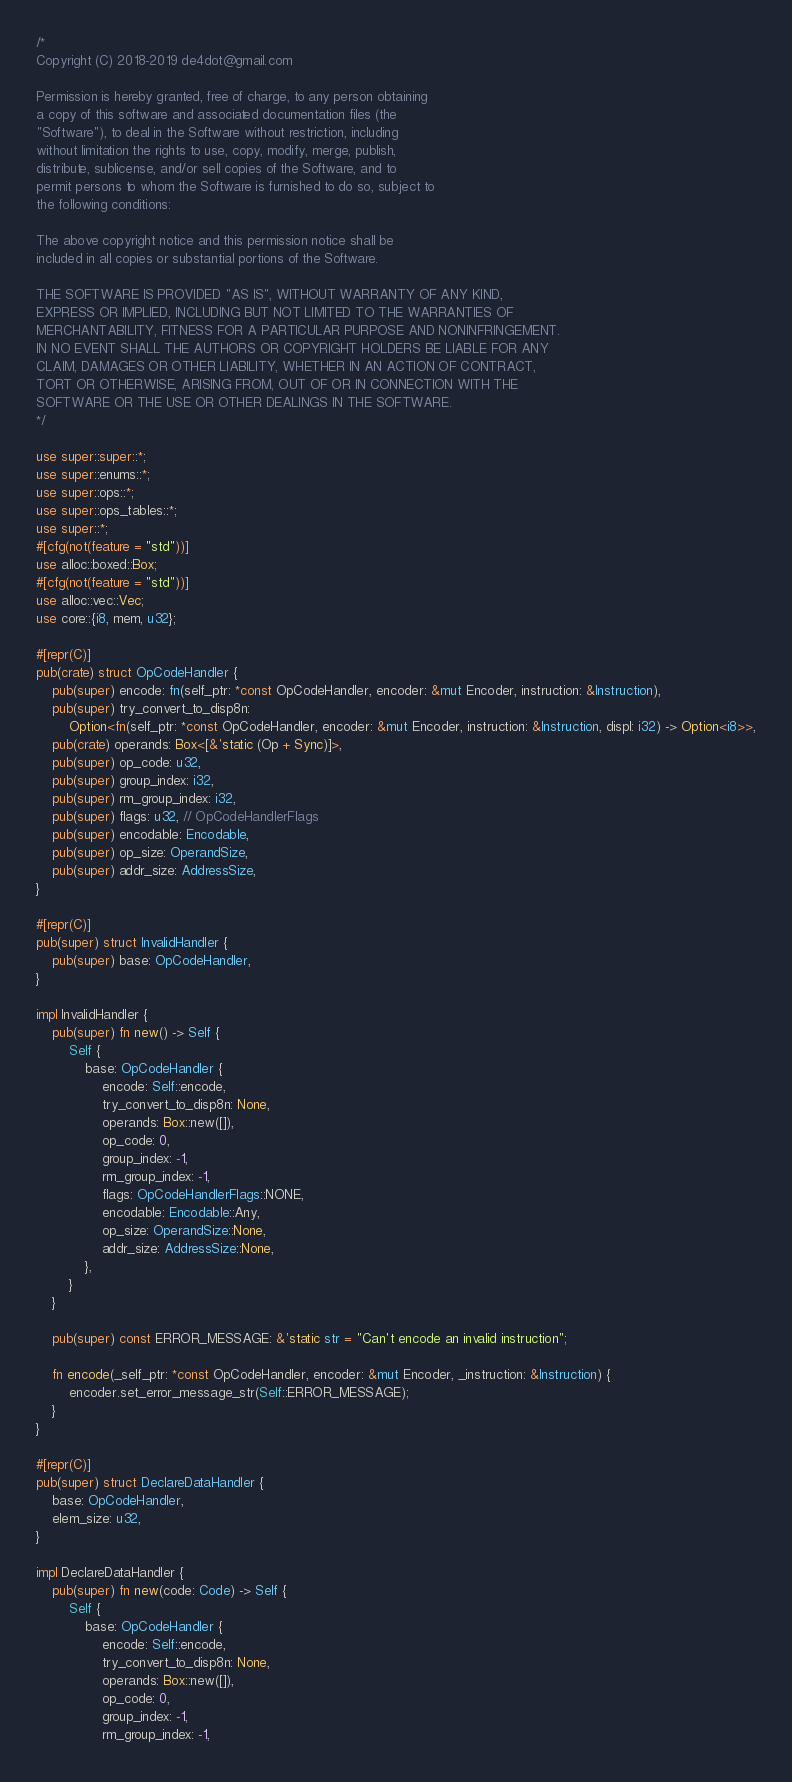Convert code to text. <code><loc_0><loc_0><loc_500><loc_500><_Rust_>/*
Copyright (C) 2018-2019 de4dot@gmail.com

Permission is hereby granted, free of charge, to any person obtaining
a copy of this software and associated documentation files (the
"Software"), to deal in the Software without restriction, including
without limitation the rights to use, copy, modify, merge, publish,
distribute, sublicense, and/or sell copies of the Software, and to
permit persons to whom the Software is furnished to do so, subject to
the following conditions:

The above copyright notice and this permission notice shall be
included in all copies or substantial portions of the Software.

THE SOFTWARE IS PROVIDED "AS IS", WITHOUT WARRANTY OF ANY KIND,
EXPRESS OR IMPLIED, INCLUDING BUT NOT LIMITED TO THE WARRANTIES OF
MERCHANTABILITY, FITNESS FOR A PARTICULAR PURPOSE AND NONINFRINGEMENT.
IN NO EVENT SHALL THE AUTHORS OR COPYRIGHT HOLDERS BE LIABLE FOR ANY
CLAIM, DAMAGES OR OTHER LIABILITY, WHETHER IN AN ACTION OF CONTRACT,
TORT OR OTHERWISE, ARISING FROM, OUT OF OR IN CONNECTION WITH THE
SOFTWARE OR THE USE OR OTHER DEALINGS IN THE SOFTWARE.
*/

use super::super::*;
use super::enums::*;
use super::ops::*;
use super::ops_tables::*;
use super::*;
#[cfg(not(feature = "std"))]
use alloc::boxed::Box;
#[cfg(not(feature = "std"))]
use alloc::vec::Vec;
use core::{i8, mem, u32};

#[repr(C)]
pub(crate) struct OpCodeHandler {
	pub(super) encode: fn(self_ptr: *const OpCodeHandler, encoder: &mut Encoder, instruction: &Instruction),
	pub(super) try_convert_to_disp8n:
		Option<fn(self_ptr: *const OpCodeHandler, encoder: &mut Encoder, instruction: &Instruction, displ: i32) -> Option<i8>>,
	pub(crate) operands: Box<[&'static (Op + Sync)]>,
	pub(super) op_code: u32,
	pub(super) group_index: i32,
	pub(super) rm_group_index: i32,
	pub(super) flags: u32, // OpCodeHandlerFlags
	pub(super) encodable: Encodable,
	pub(super) op_size: OperandSize,
	pub(super) addr_size: AddressSize,
}

#[repr(C)]
pub(super) struct InvalidHandler {
	pub(super) base: OpCodeHandler,
}

impl InvalidHandler {
	pub(super) fn new() -> Self {
		Self {
			base: OpCodeHandler {
				encode: Self::encode,
				try_convert_to_disp8n: None,
				operands: Box::new([]),
				op_code: 0,
				group_index: -1,
				rm_group_index: -1,
				flags: OpCodeHandlerFlags::NONE,
				encodable: Encodable::Any,
				op_size: OperandSize::None,
				addr_size: AddressSize::None,
			},
		}
	}

	pub(super) const ERROR_MESSAGE: &'static str = "Can't encode an invalid instruction";

	fn encode(_self_ptr: *const OpCodeHandler, encoder: &mut Encoder, _instruction: &Instruction) {
		encoder.set_error_message_str(Self::ERROR_MESSAGE);
	}
}

#[repr(C)]
pub(super) struct DeclareDataHandler {
	base: OpCodeHandler,
	elem_size: u32,
}

impl DeclareDataHandler {
	pub(super) fn new(code: Code) -> Self {
		Self {
			base: OpCodeHandler {
				encode: Self::encode,
				try_convert_to_disp8n: None,
				operands: Box::new([]),
				op_code: 0,
				group_index: -1,
				rm_group_index: -1,</code> 